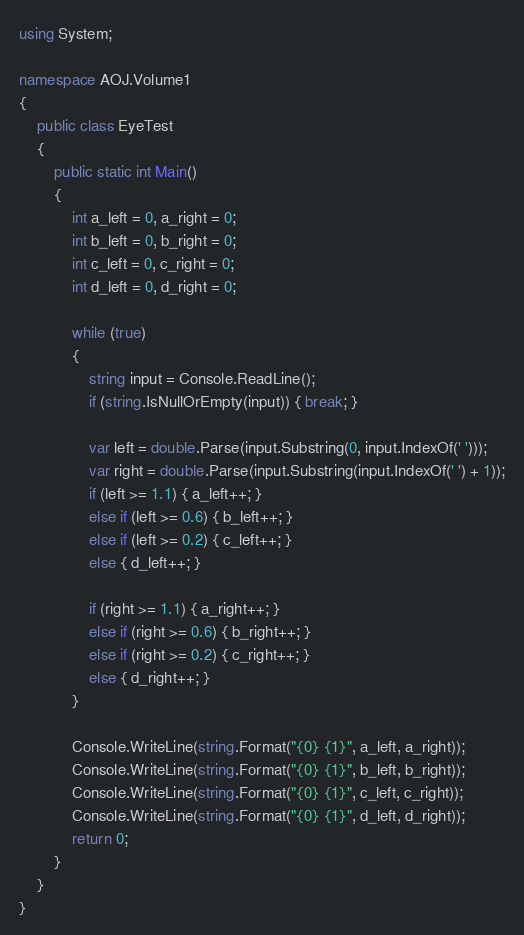<code> <loc_0><loc_0><loc_500><loc_500><_C#_>using System;

namespace AOJ.Volume1
{
    public class EyeTest
    {
        public static int Main()
        {
            int a_left = 0, a_right = 0;
            int b_left = 0, b_right = 0;
            int c_left = 0, c_right = 0;
            int d_left = 0, d_right = 0;

            while (true)
            {
                string input = Console.ReadLine();
                if (string.IsNullOrEmpty(input)) { break; }

                var left = double.Parse(input.Substring(0, input.IndexOf(' ')));
                var right = double.Parse(input.Substring(input.IndexOf(' ') + 1));
                if (left >= 1.1) { a_left++; }
                else if (left >= 0.6) { b_left++; }
                else if (left >= 0.2) { c_left++; }
                else { d_left++; }

                if (right >= 1.1) { a_right++; }
                else if (right >= 0.6) { b_right++; }
                else if (right >= 0.2) { c_right++; }
                else { d_right++; }
            }

            Console.WriteLine(string.Format("{0} {1}", a_left, a_right));
            Console.WriteLine(string.Format("{0} {1}", b_left, b_right));
            Console.WriteLine(string.Format("{0} {1}", c_left, c_right));
            Console.WriteLine(string.Format("{0} {1}", d_left, d_right));
            return 0;
        }
    }
}</code> 